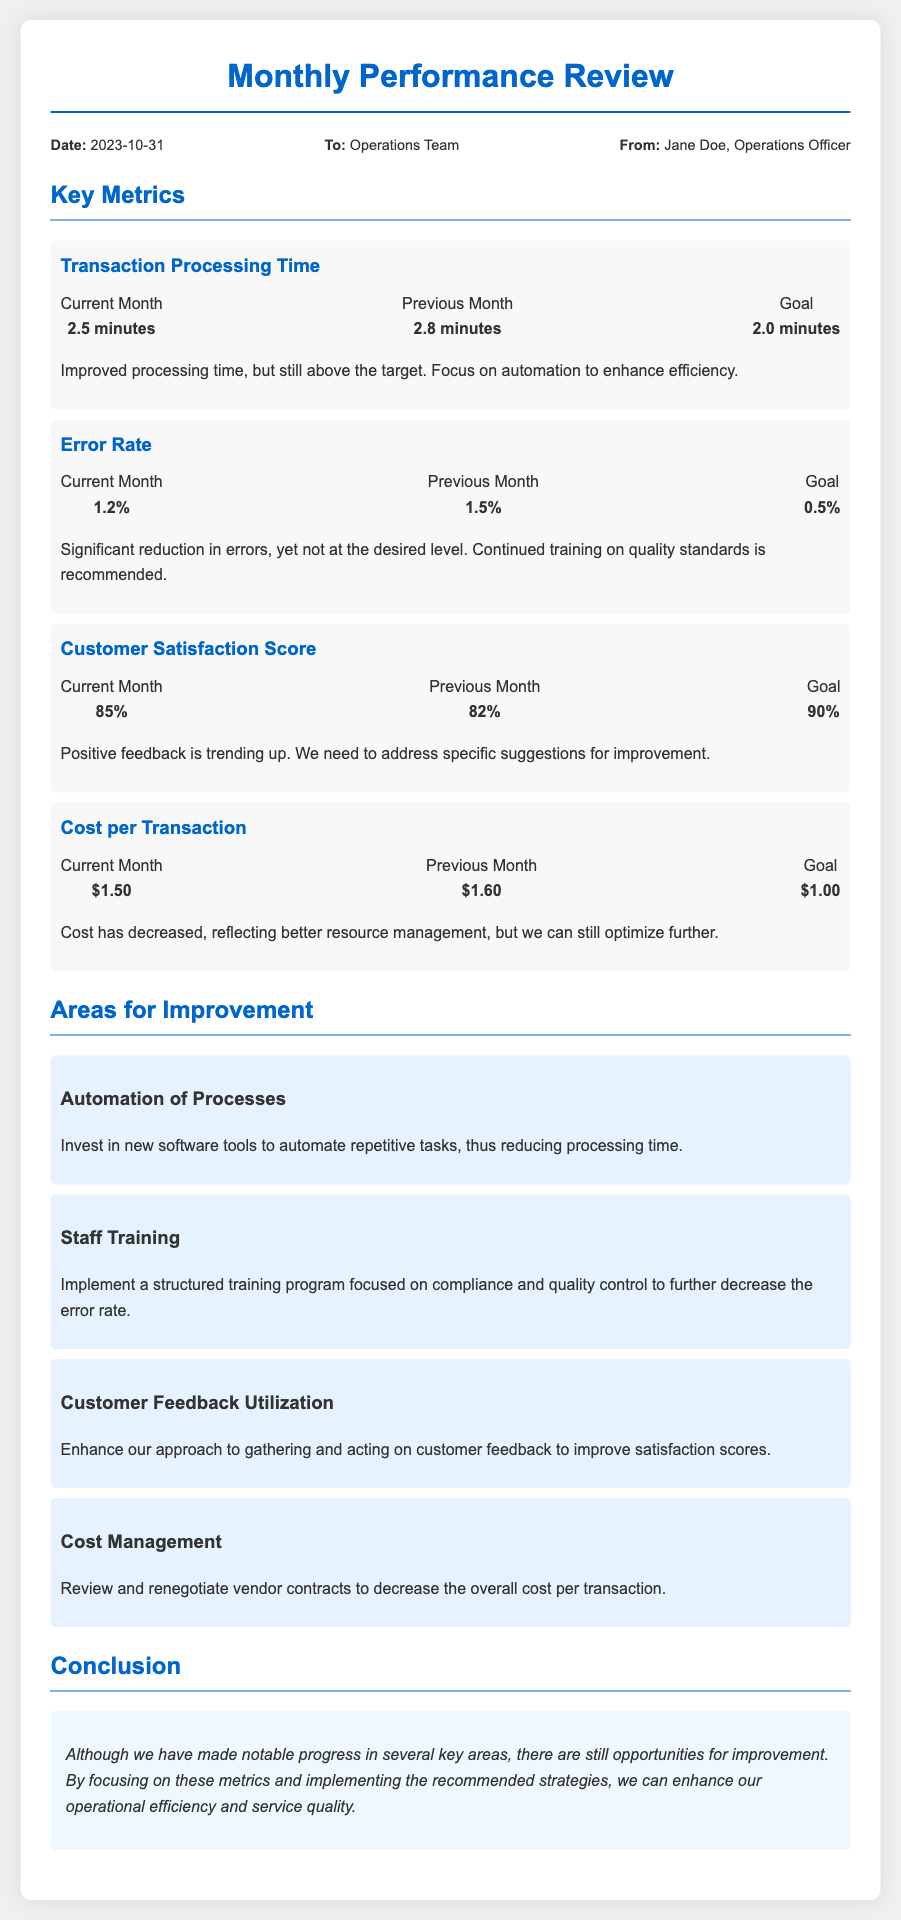what was the date of the memo? The date provided in the memo is indicated in the meta section, stating "Date: 2023-10-31".
Answer: 2023-10-31 who is the author of the memo? The author of the memo is identified in the meta section as "Jane Doe, Operations Officer".
Answer: Jane Doe what is the current error rate for the operations department? The current error rate is listed under the Error Rate metric as "1.2%".
Answer: 1.2% what improvement is recommended for transaction processing time? The memo suggests focusing on "automation to enhance efficiency" to improve processing time.
Answer: automation to enhance efficiency how much has the cost per transaction decreased from the previous month? The cost per transaction dropped from "$1.60" in the previous month to "$1.50" in the current month, indicating a decrease of "$0.10".
Answer: $0.10 what is the goal for customer satisfaction score? The goal for customer satisfaction score is indicated as "90%".
Answer: 90% which area suggests enhancing the approach to customer feedback? The improvement area suggests "Customer Feedback Utilization" to improve satisfaction scores.
Answer: Customer Feedback Utilization what notable progress is mentioned in the conclusion? The conclusion mentions "notable progress in several key areas" but highlights opportunities for improvement.
Answer: notable progress in several key areas 